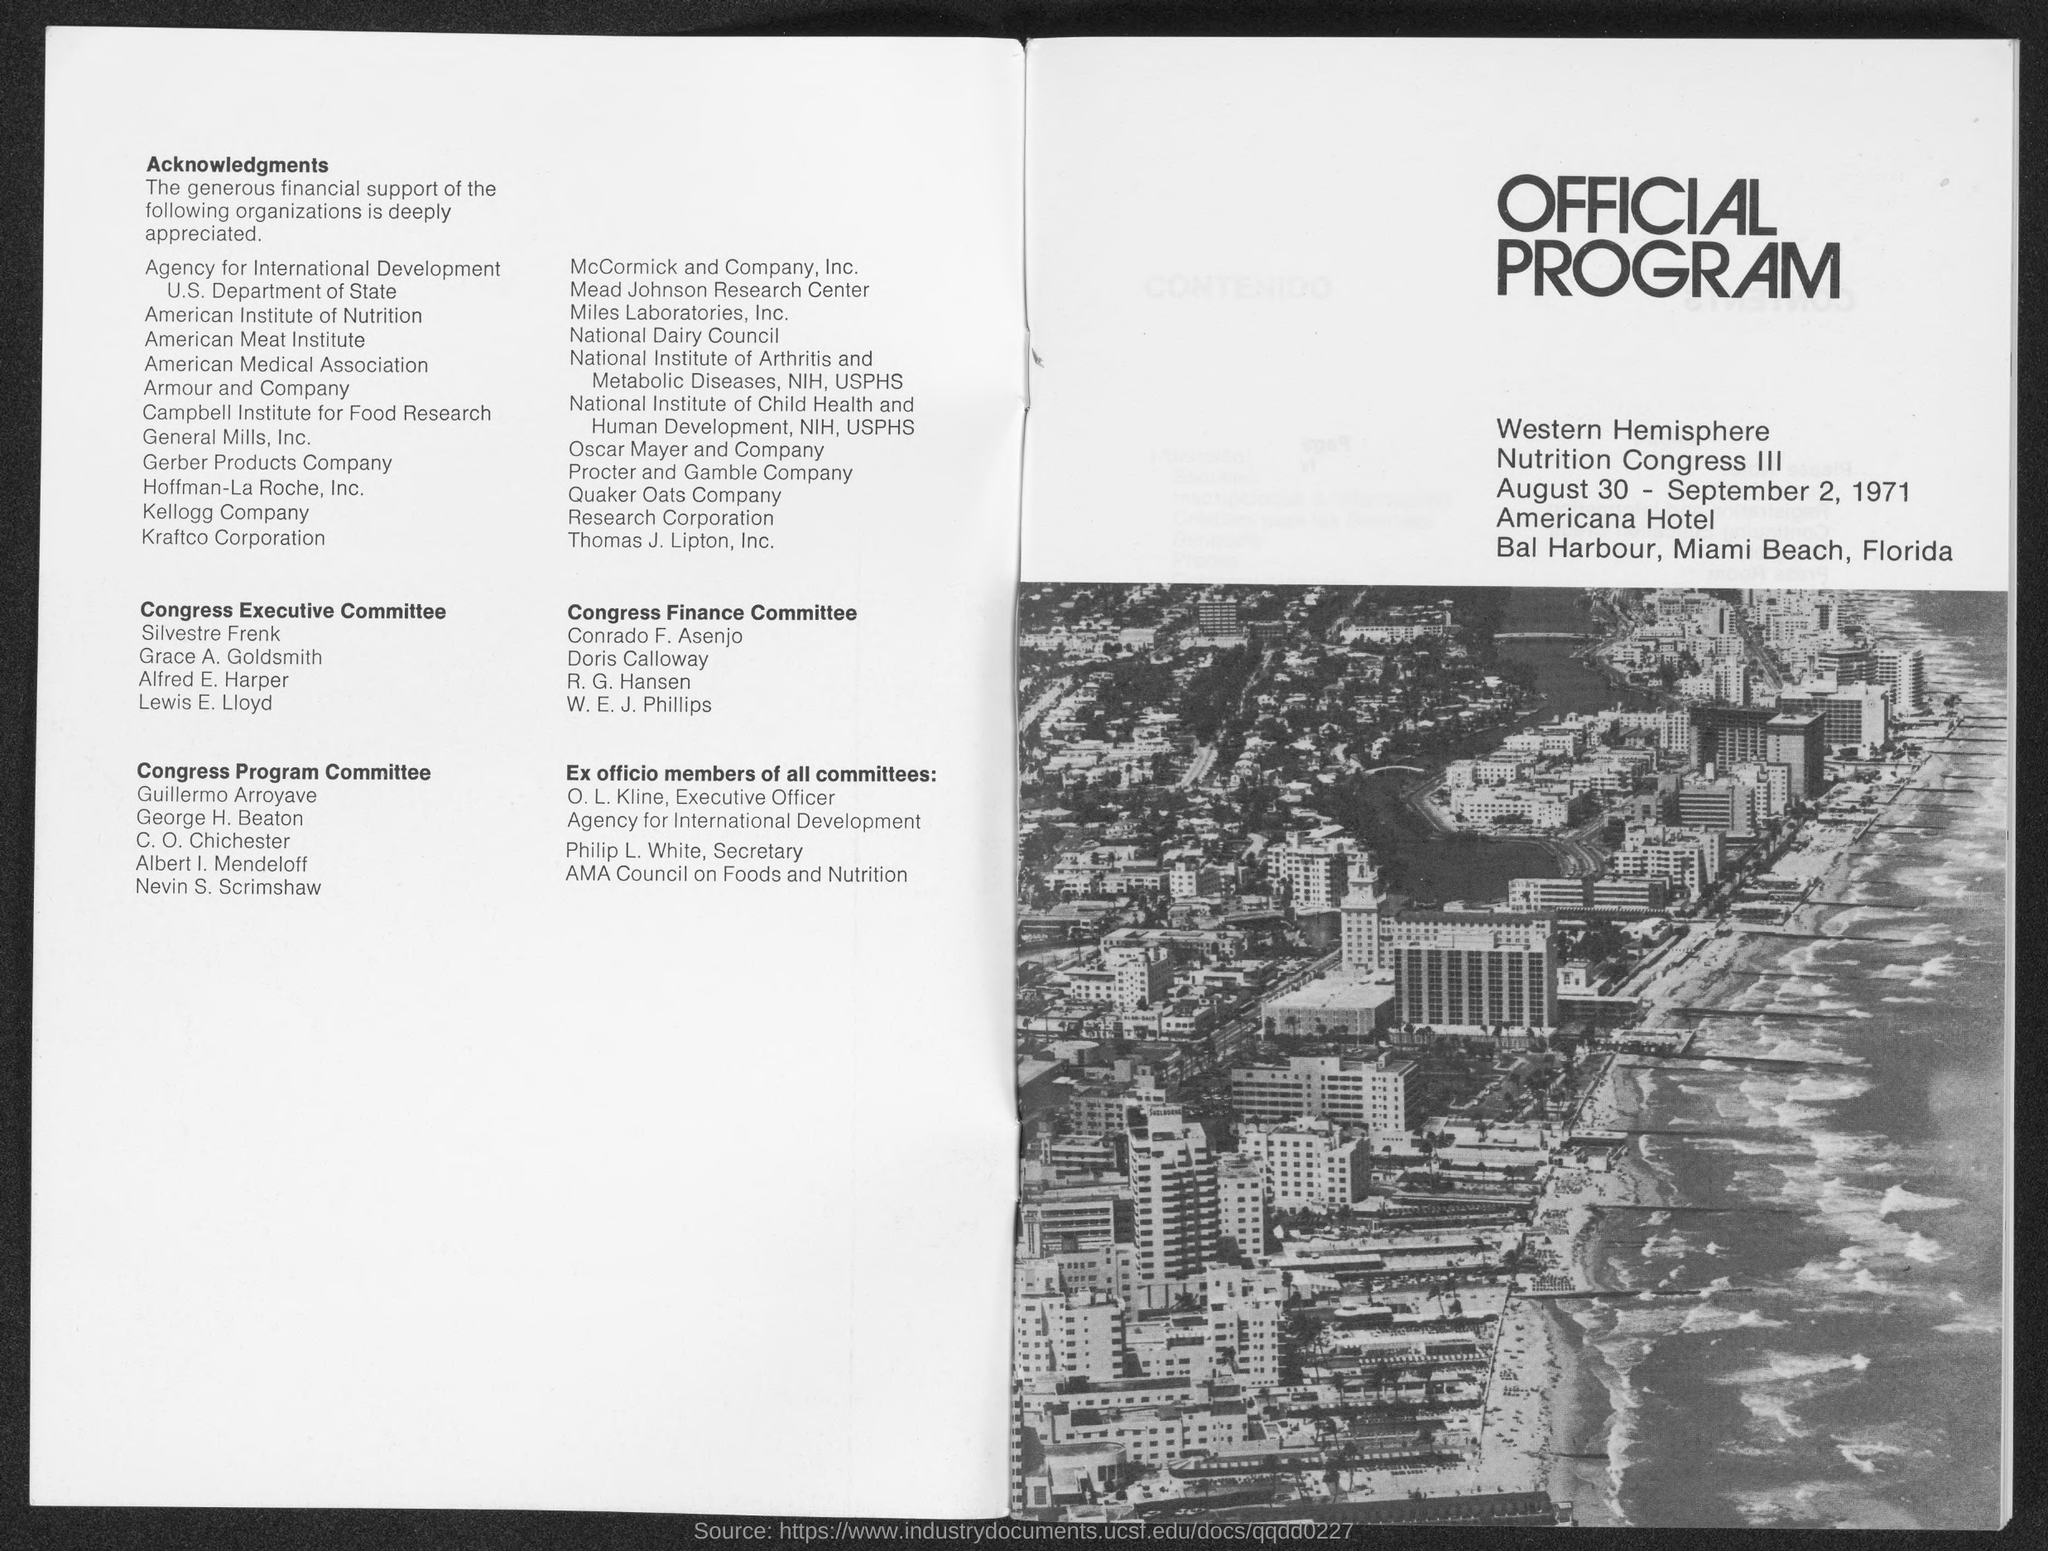When the official program is conducted ?
Keep it short and to the point. August 30 - September 2, 1971. In which beach, does the program is conducted ?
Provide a succinct answer. Miami Beach. Who is the first member of the "Congress Finance Committee" ?
Offer a terse response. Conrado F. Asenjo. Who is the first member of the "Congress Executive Committee"?
Ensure brevity in your answer.  Silvestre Frenk. Who is the last member of the "Congress Executive Committee"?
Your answer should be very brief. Lewis E. Lloyd. Who is the secretary of "AMA Council on Foods and Nutrition" ?
Make the answer very short. Philip L. White,. Who is the last member of the "Congress Finance Committee" ?
Your response must be concise. W. E. J. Phillips. Who is the last member of the "Congress Program Committee"?
Offer a very short reply. Nevin S. Scrimshaw. 